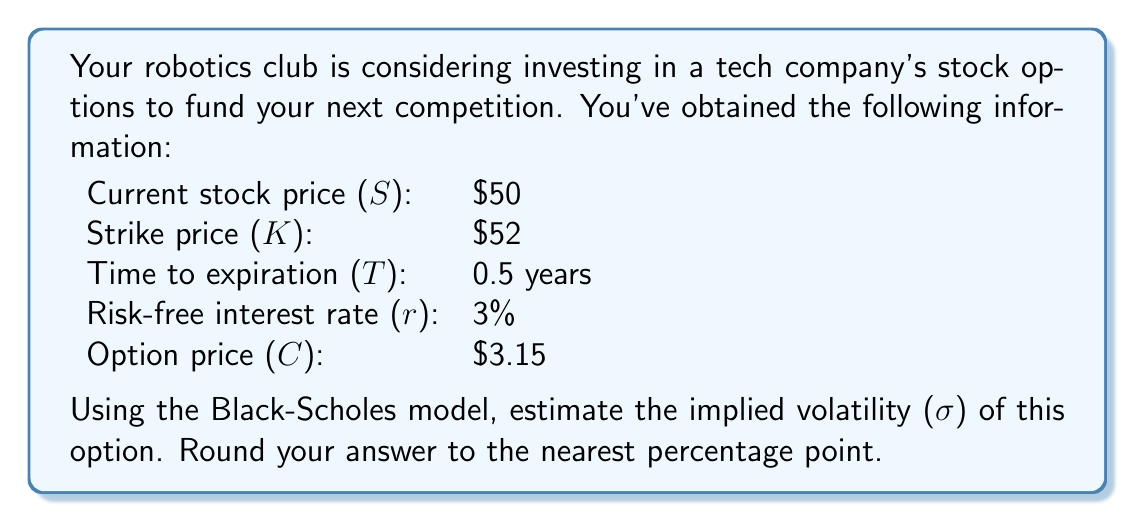Could you help me with this problem? To estimate the implied volatility using the Black-Scholes model, we need to use an iterative approach, as there's no closed-form solution. We'll use the Newton-Raphson method.

The Black-Scholes formula for a call option is:

$$C = SN(d_1) - Ke^{-rT}N(d_2)$$

where:

$$d_1 = \frac{\ln(S/K) + (r + \sigma^2/2)T}{\sigma\sqrt{T}}$$
$$d_2 = d_1 - \sigma\sqrt{T}$$

We'll start with an initial guess for σ (let's use 30%) and iterate until we find a value that gives us the observed option price.

Step 1: Initial guess
σ = 0.30

Step 2: Calculate d1 and d2
$$d_1 = \frac{\ln(50/52) + (0.03 + 0.30^2/2)(0.5)}{0.30\sqrt{0.5}} = -0.0936$$
$$d_2 = -0.0936 - 0.30\sqrt{0.5} = -0.3056$$

Step 3: Calculate N(d1) and N(d2) using the standard normal cumulative distribution function
N(d1) = 0.4627
N(d2) = 0.3800

Step 4: Calculate the option price using the Black-Scholes formula
$$C = 50 * 0.4627 - 52e^{-0.03*0.5} * 0.3800 = 2.8135$$

Step 5: Calculate the option's vega (sensitivity to volatility)
$$vega = S\sqrt{T}n(d_1) = 50 * \sqrt{0.5} * 0.3969 = 14.0252$$

Step 6: Update σ using the Newton-Raphson method
$$\sigma_{new} = \sigma_{old} + \frac{C_{market} - C_{calculated}}{vega}$$
$$\sigma_{new} = 0.30 + \frac{3.15 - 2.8135}{14.0252} = 0.3239$$

Repeat steps 2-6 until the calculated option price is close to the market price.

After a few iterations, we converge to:
σ ≈ 0.3437 or 34.37%

Rounding to the nearest percentage point, we get 34%.
Answer: 34% 